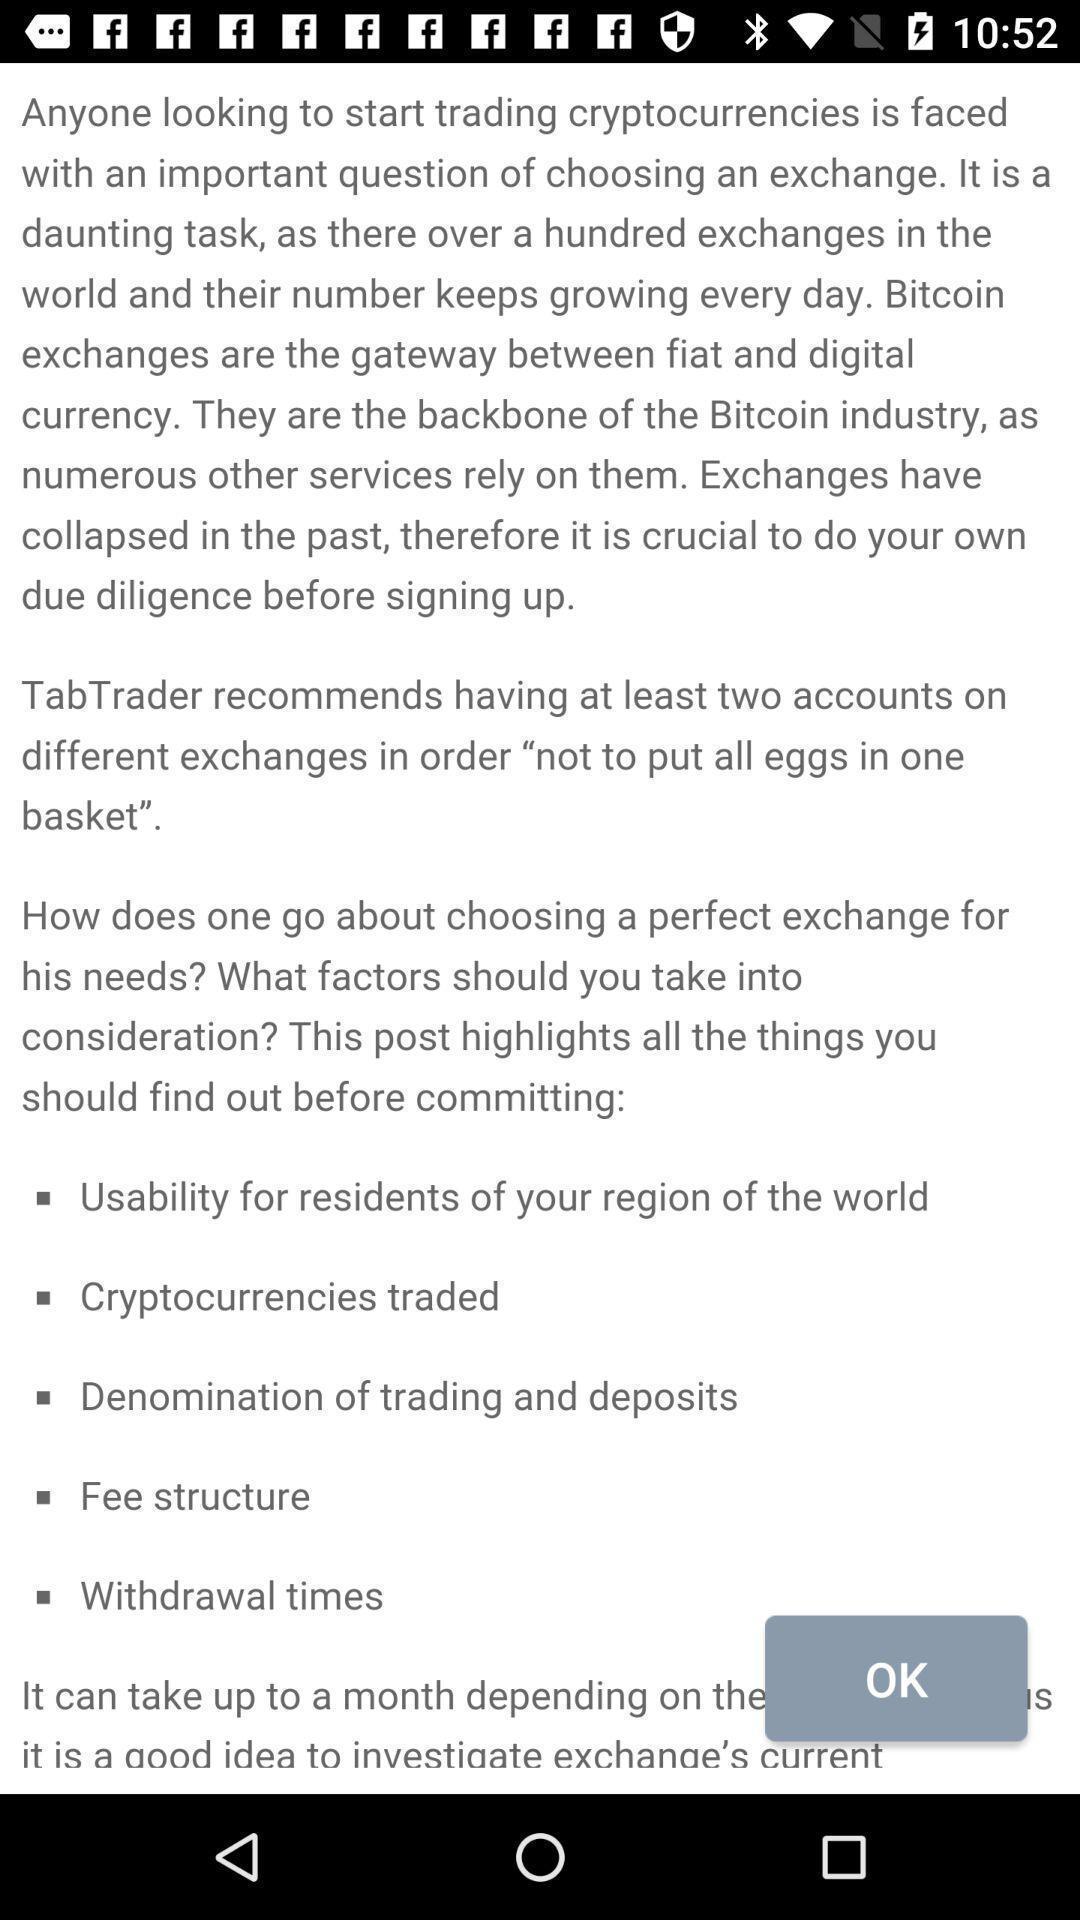Describe the visual elements of this screenshot. Page showing information about trading. 